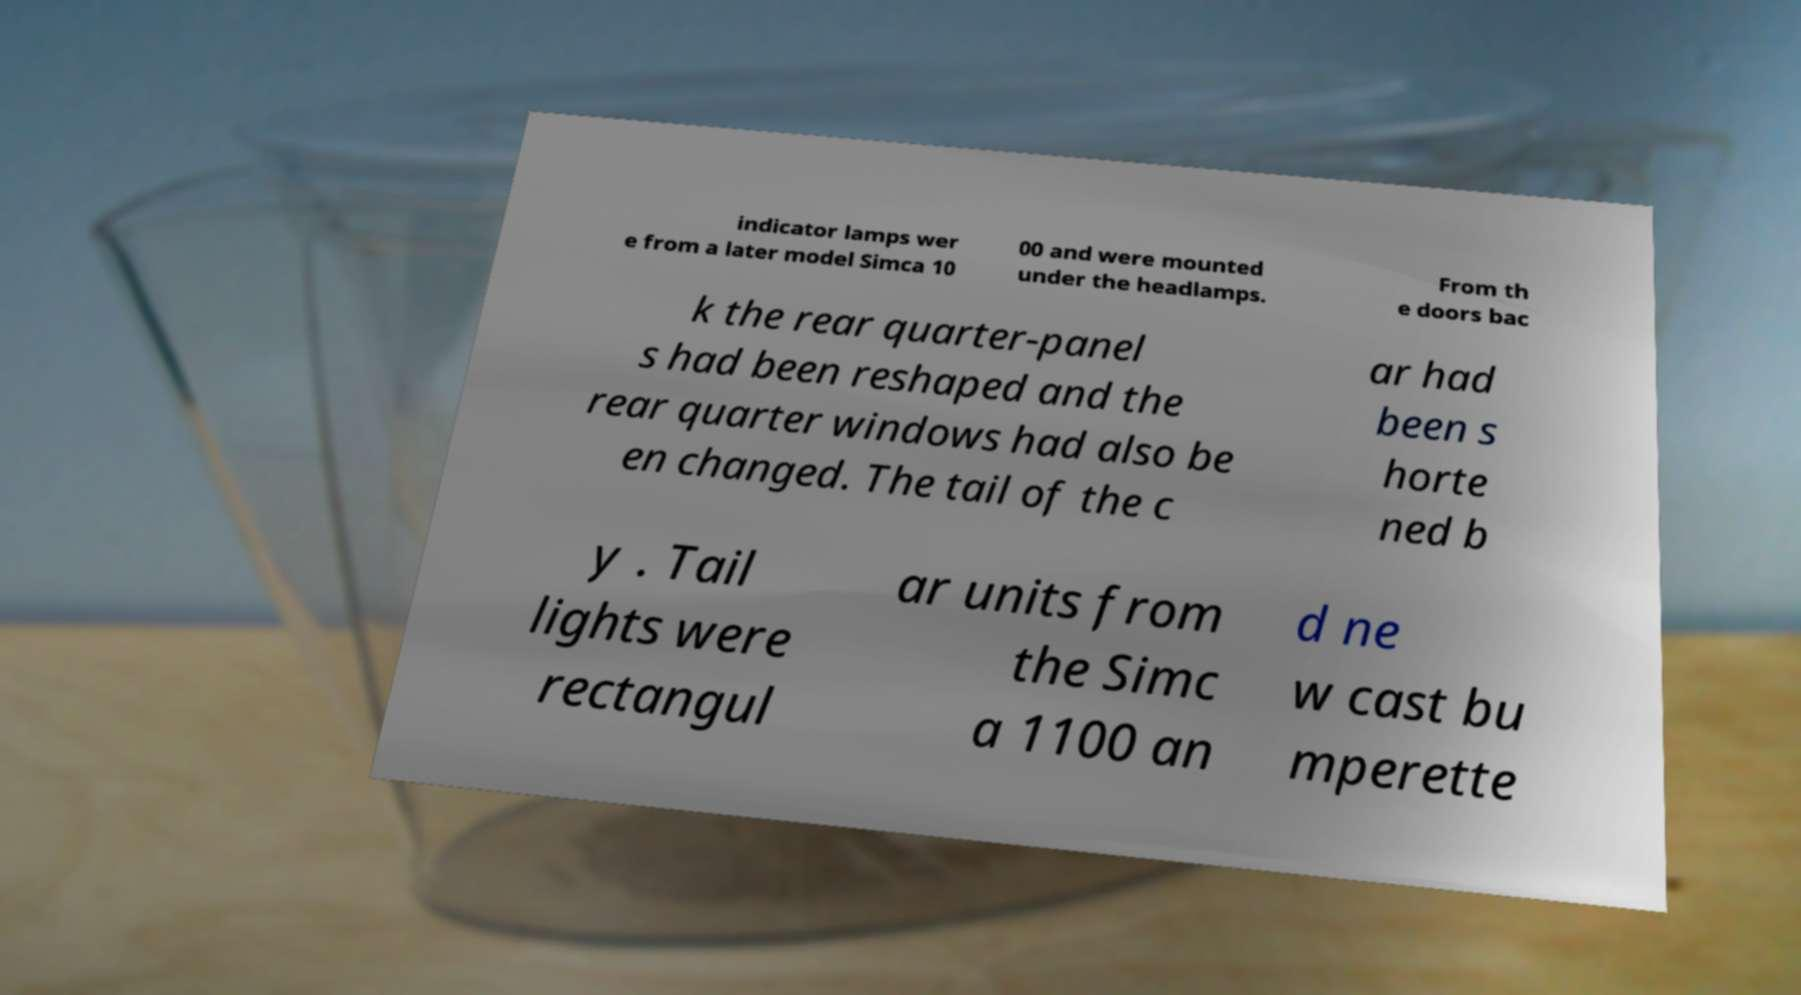Could you assist in decoding the text presented in this image and type it out clearly? indicator lamps wer e from a later model Simca 10 00 and were mounted under the headlamps. From th e doors bac k the rear quarter-panel s had been reshaped and the rear quarter windows had also be en changed. The tail of the c ar had been s horte ned b y . Tail lights were rectangul ar units from the Simc a 1100 an d ne w cast bu mperette 